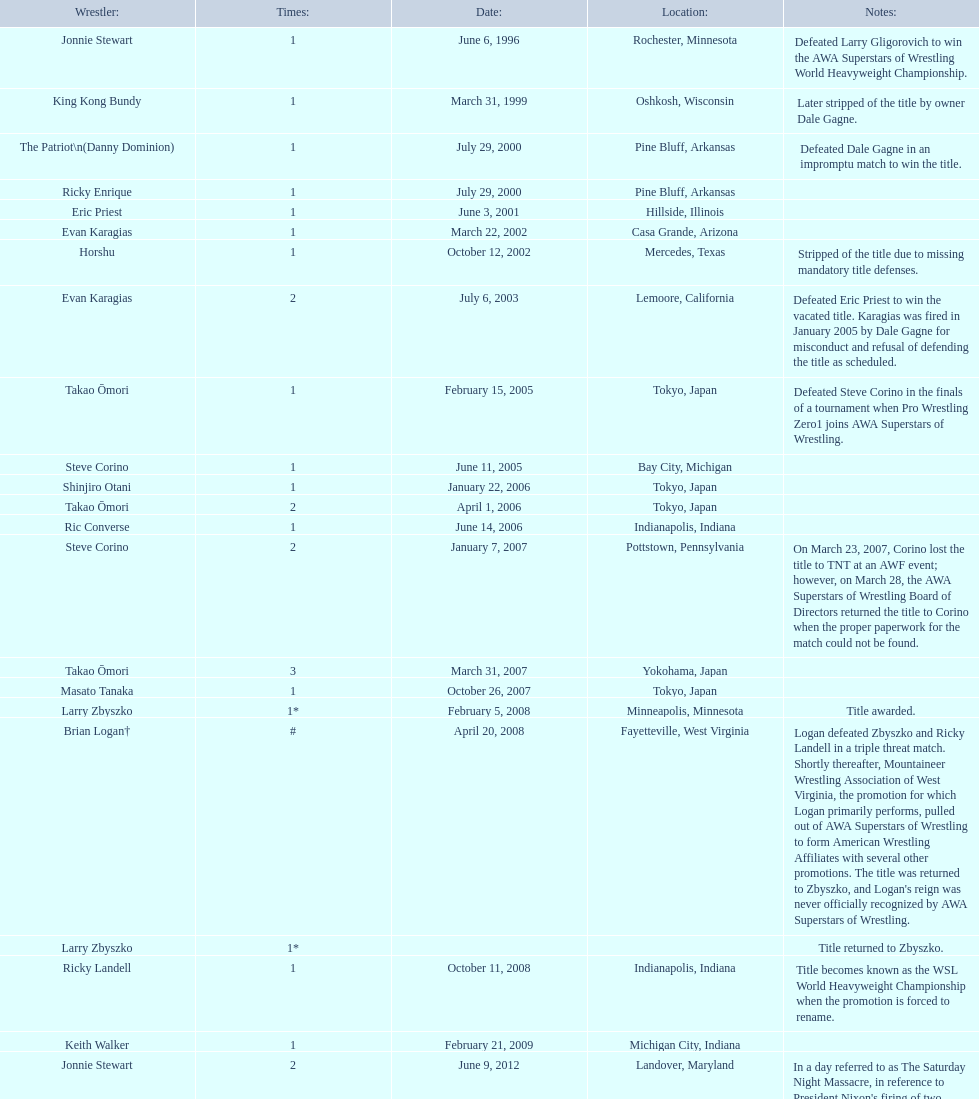How many instances has ricky landell won the wsl title? 1. 